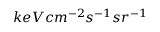<formula> <loc_0><loc_0><loc_500><loc_500>k e V c m ^ { - 2 } s ^ { - 1 } s r ^ { - 1 }</formula> 